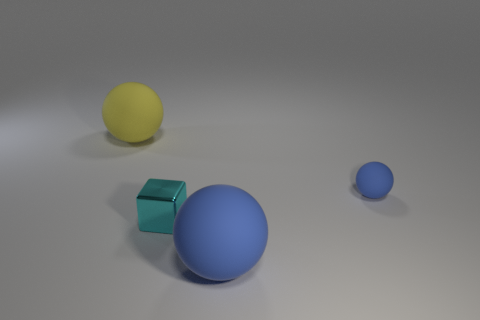Subtract all blue matte spheres. How many spheres are left? 1 Subtract all gray cylinders. How many blue spheres are left? 2 Add 2 rubber balls. How many objects exist? 6 Subtract all balls. How many objects are left? 1 Subtract all big yellow matte spheres. Subtract all big matte things. How many objects are left? 1 Add 4 tiny cyan things. How many tiny cyan things are left? 5 Add 2 tiny rubber spheres. How many tiny rubber spheres exist? 3 Subtract 0 purple cylinders. How many objects are left? 4 Subtract all blue spheres. Subtract all purple cubes. How many spheres are left? 1 